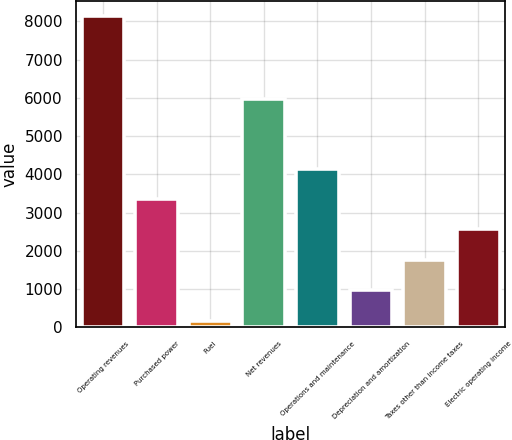Convert chart. <chart><loc_0><loc_0><loc_500><loc_500><bar_chart><fcel>Operating revenues<fcel>Purchased power<fcel>Fuel<fcel>Net revenues<fcel>Operations and maintenance<fcel>Depreciation and amortization<fcel>Taxes other than income taxes<fcel>Electric operating income<nl><fcel>8131<fcel>3356.8<fcel>174<fcel>5983<fcel>4152.5<fcel>969.7<fcel>1765.4<fcel>2561.1<nl></chart> 